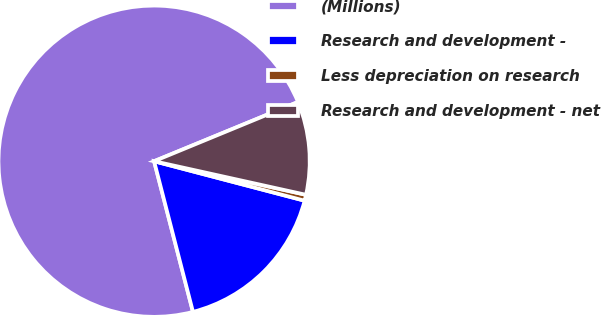Convert chart. <chart><loc_0><loc_0><loc_500><loc_500><pie_chart><fcel>(Millions)<fcel>Research and development -<fcel>Less depreciation on research<fcel>Research and development - net<nl><fcel>72.81%<fcel>16.9%<fcel>0.62%<fcel>9.68%<nl></chart> 